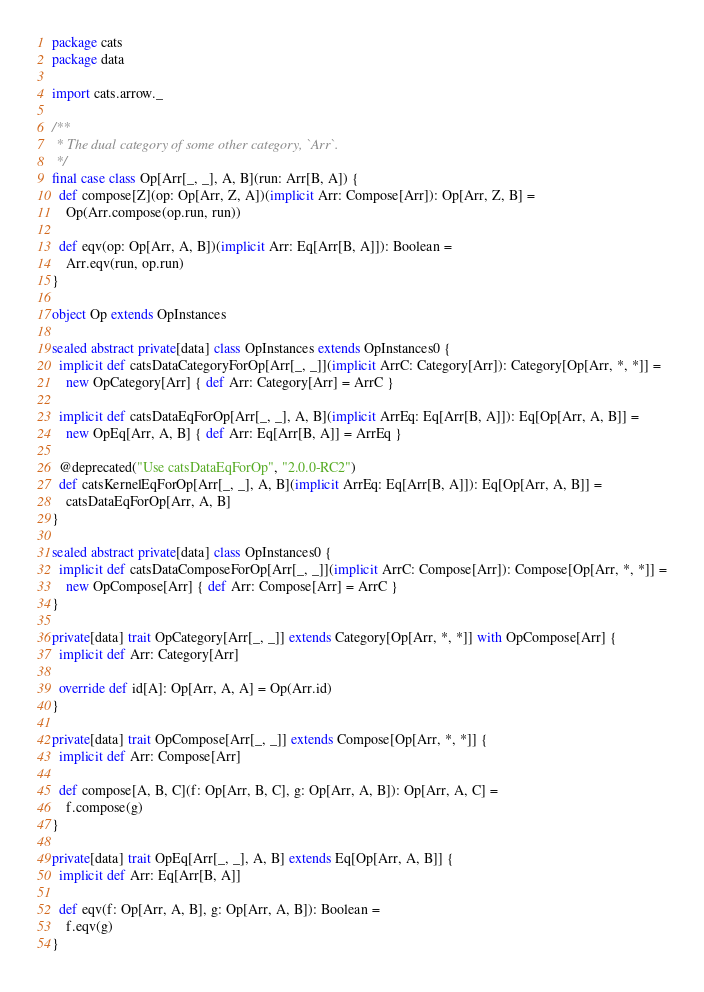Convert code to text. <code><loc_0><loc_0><loc_500><loc_500><_Scala_>package cats
package data

import cats.arrow._

/**
 * The dual category of some other category, `Arr`.
 */
final case class Op[Arr[_, _], A, B](run: Arr[B, A]) {
  def compose[Z](op: Op[Arr, Z, A])(implicit Arr: Compose[Arr]): Op[Arr, Z, B] =
    Op(Arr.compose(op.run, run))

  def eqv(op: Op[Arr, A, B])(implicit Arr: Eq[Arr[B, A]]): Boolean =
    Arr.eqv(run, op.run)
}

object Op extends OpInstances

sealed abstract private[data] class OpInstances extends OpInstances0 {
  implicit def catsDataCategoryForOp[Arr[_, _]](implicit ArrC: Category[Arr]): Category[Op[Arr, *, *]] =
    new OpCategory[Arr] { def Arr: Category[Arr] = ArrC }

  implicit def catsDataEqForOp[Arr[_, _], A, B](implicit ArrEq: Eq[Arr[B, A]]): Eq[Op[Arr, A, B]] =
    new OpEq[Arr, A, B] { def Arr: Eq[Arr[B, A]] = ArrEq }

  @deprecated("Use catsDataEqForOp", "2.0.0-RC2")
  def catsKernelEqForOp[Arr[_, _], A, B](implicit ArrEq: Eq[Arr[B, A]]): Eq[Op[Arr, A, B]] =
    catsDataEqForOp[Arr, A, B]
}

sealed abstract private[data] class OpInstances0 {
  implicit def catsDataComposeForOp[Arr[_, _]](implicit ArrC: Compose[Arr]): Compose[Op[Arr, *, *]] =
    new OpCompose[Arr] { def Arr: Compose[Arr] = ArrC }
}

private[data] trait OpCategory[Arr[_, _]] extends Category[Op[Arr, *, *]] with OpCompose[Arr] {
  implicit def Arr: Category[Arr]

  override def id[A]: Op[Arr, A, A] = Op(Arr.id)
}

private[data] trait OpCompose[Arr[_, _]] extends Compose[Op[Arr, *, *]] {
  implicit def Arr: Compose[Arr]

  def compose[A, B, C](f: Op[Arr, B, C], g: Op[Arr, A, B]): Op[Arr, A, C] =
    f.compose(g)
}

private[data] trait OpEq[Arr[_, _], A, B] extends Eq[Op[Arr, A, B]] {
  implicit def Arr: Eq[Arr[B, A]]

  def eqv(f: Op[Arr, A, B], g: Op[Arr, A, B]): Boolean =
    f.eqv(g)
}
</code> 